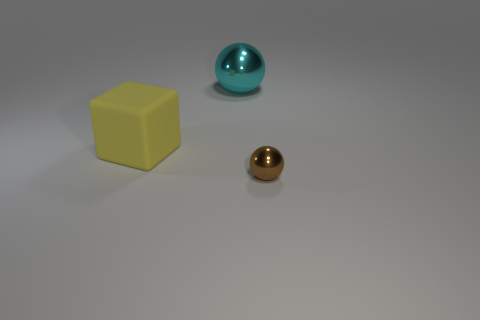How many things are brown things or things that are left of the small brown metal sphere?
Your answer should be compact. 3. What is the material of the object that is both right of the yellow thing and in front of the cyan metal object?
Give a very brief answer. Metal. Is there anything else that has the same shape as the yellow rubber object?
Your answer should be compact. No. What is the color of the other tiny sphere that is made of the same material as the cyan ball?
Offer a very short reply. Brown. How many objects are rubber blocks or large blue metal cylinders?
Your answer should be compact. 1. Do the brown shiny thing and the sphere behind the tiny brown metal object have the same size?
Keep it short and to the point. No. There is a large matte cube that is behind the ball in front of the metallic ball that is behind the big yellow rubber object; what color is it?
Ensure brevity in your answer.  Yellow. What is the color of the large cube?
Your answer should be very brief. Yellow. Is the number of rubber things right of the small thing greater than the number of rubber things that are on the right side of the cyan sphere?
Your answer should be very brief. No. Does the yellow matte object have the same shape as the big object behind the rubber thing?
Offer a very short reply. No. 